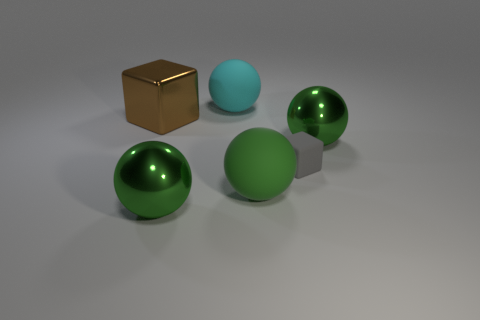Is the number of green balls that are right of the gray thing the same as the number of brown rubber cubes?
Your response must be concise. No. Do the small rubber thing and the large shiny block have the same color?
Offer a very short reply. No. There is a thing that is to the left of the cyan matte thing and in front of the brown shiny object; what size is it?
Provide a short and direct response. Large. What color is the big thing that is made of the same material as the cyan ball?
Keep it short and to the point. Green. How many big brown cubes are the same material as the big cyan ball?
Make the answer very short. 0. Is the number of large shiny things that are behind the small block the same as the number of brown cubes on the left side of the brown metal thing?
Your answer should be compact. No. Does the gray object have the same shape as the thing behind the brown cube?
Offer a terse response. No. Are there any other things that have the same shape as the small thing?
Keep it short and to the point. Yes. Are the cyan sphere and the green thing to the left of the big cyan matte sphere made of the same material?
Offer a very short reply. No. What is the color of the cube right of the green rubber sphere in front of the large shiny sphere right of the green matte thing?
Offer a very short reply. Gray. 